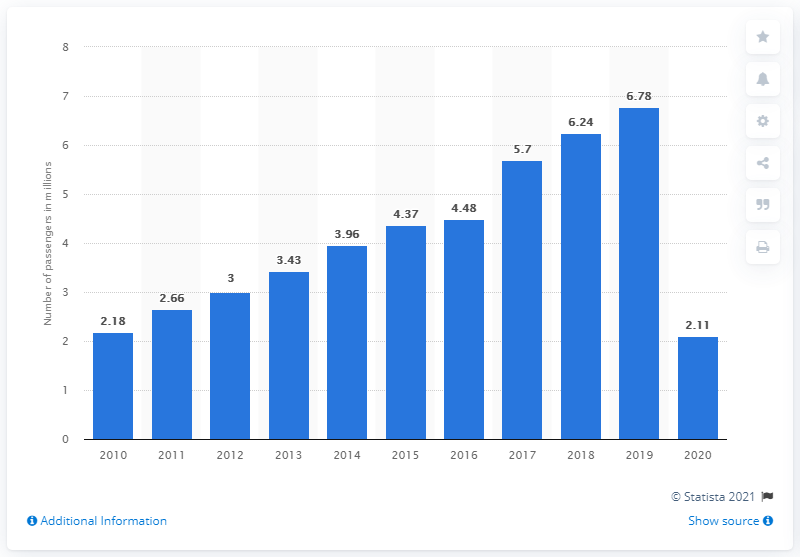Mention a couple of crucial points in this snapshot. In 2020, approximately 2.11 million passengers used Eindhoven Airport to fly from or arrive in the Netherlands. 